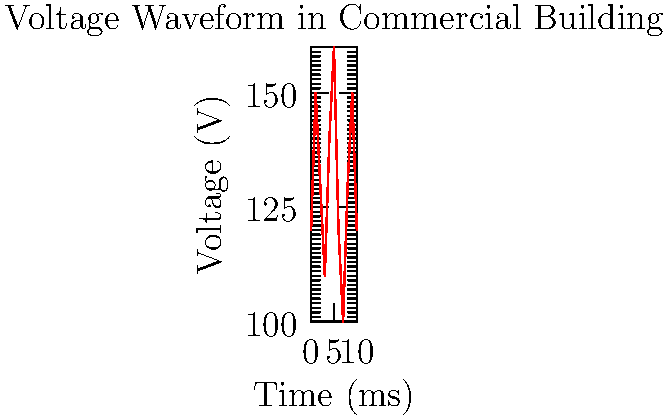As an HR professional in a retail chain, you're analyzing industry trends in power quality. The graph shows a voltage waveform recorded in a commercial building. What power quality issue does this waveform most likely indicate? To analyze this waveform and identify the power quality issue:

1. Observe the overall pattern: The voltage fluctuates irregularly around a nominal value.

2. Note the nominal voltage: It appears to be around 120V, which is standard for many commercial buildings in the US.

3. Identify the deviations: There are both overvoltages (peaks above 120V) and undervoltages (dips below 120V).

4. Assess the magnitude of fluctuations: Variations range from about 100V to 160V, which is significant.

5. Consider the timeframe: These fluctuations occur rapidly, within milliseconds.

6. Compare to known power quality issues:
   - Voltage sags/swells typically last longer and don't alternate as rapidly.
   - Harmonics usually show a consistent pattern of distortion.
   - Transients are typically much shorter in duration.

7. Conclude: The rapid, irregular fluctuations in voltage magnitude are characteristic of voltage flicker.

Voltage flicker is often caused by large, fluctuating loads in nearby facilities, such as arc furnaces or large motor starts. It can affect lighting quality and sensitive electronic equipment, which is relevant to retail environments.
Answer: Voltage flicker 